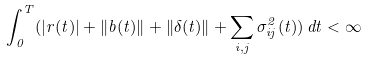Convert formula to latex. <formula><loc_0><loc_0><loc_500><loc_500>\int _ { 0 } ^ { T } ( \left | r ( t ) \right | + \left \| b ( t ) \right \| + \left \| \delta ( t ) \right \| + \sum _ { i , j } \sigma _ { i j } ^ { 2 } ( t ) ) \, d t < \infty</formula> 